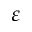Convert formula to latex. <formula><loc_0><loc_0><loc_500><loc_500>\varepsilon</formula> 